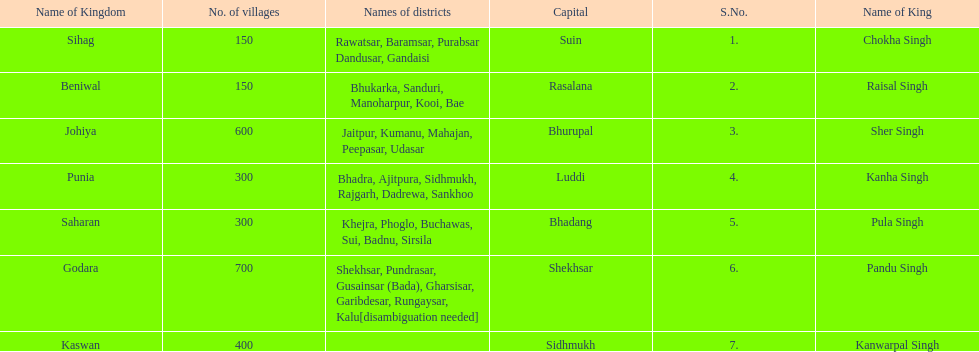What was the total number of districts within the state of godara? 7. 